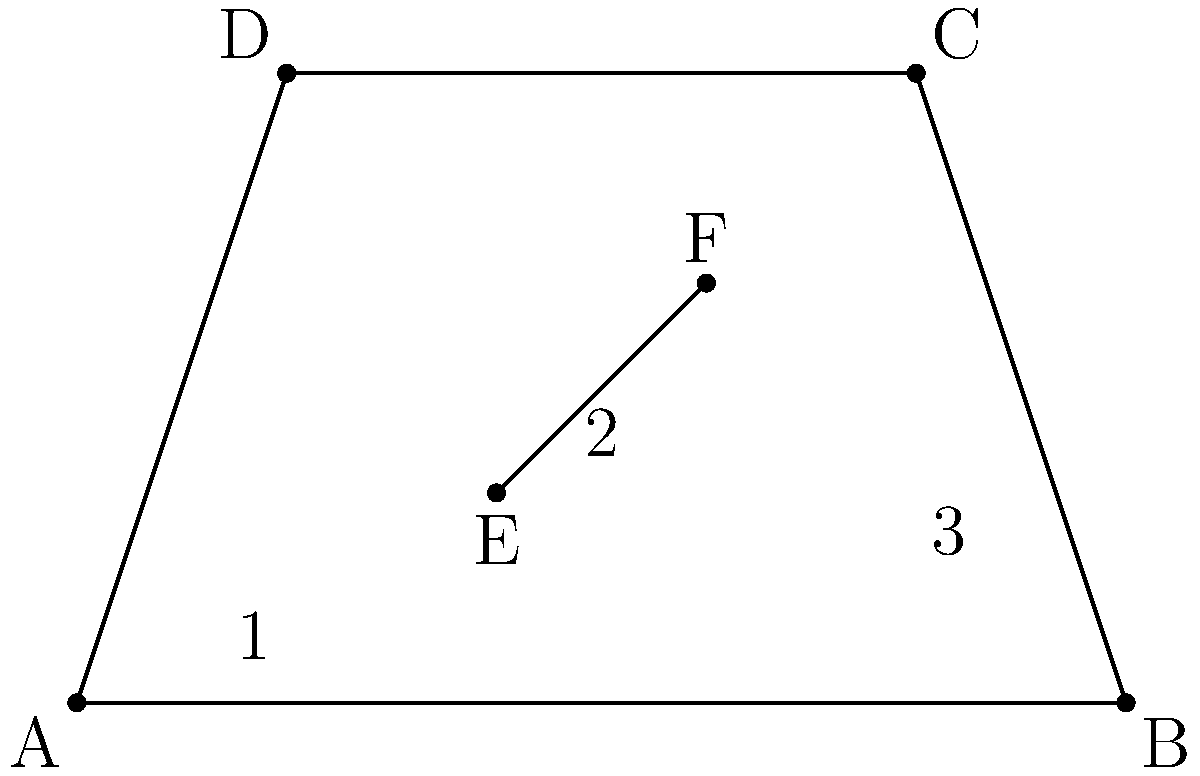In the perspective drawing above, compare the apparent lengths of segments 1, 2, and 3. Which segment appears to be the longest, and which appears to be the shortest? To answer this question, we need to analyze the spatial relationships in the perspective drawing:

1. First, note that the drawing represents a three-dimensional space on a two-dimensional plane.

2. Segment 1 is in the foreground of the image, closest to the viewer. It appears longer due to its proximity.

3. Segment 3 is in the background of the image, farthest from the viewer. It appears shorter due to its distance.

4. Segment 2 is in the middle ground, between segments 1 and 3.

5. In perspective drawings, objects closer to the viewer appear larger, while objects farther away appear smaller. This is known as linear perspective.

6. Despite the actual lengths of the segments potentially being different, the perspective effect makes segment 1 appear the longest and segment 3 appear the shortest.

7. The apparent length of segment 2 falls between segments 1 and 3 due to its intermediate position in the perspective.

Therefore, based on the principles of spatial perception and perspective drawing, segment 1 appears to be the longest, and segment 3 appears to be the shortest.
Answer: Longest: 1, Shortest: 3 